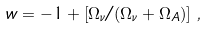Convert formula to latex. <formula><loc_0><loc_0><loc_500><loc_500>w = - 1 + \left [ \Omega _ { \nu } / ( \Omega _ { \nu } + \Omega _ { A } ) \right ] \, ,</formula> 